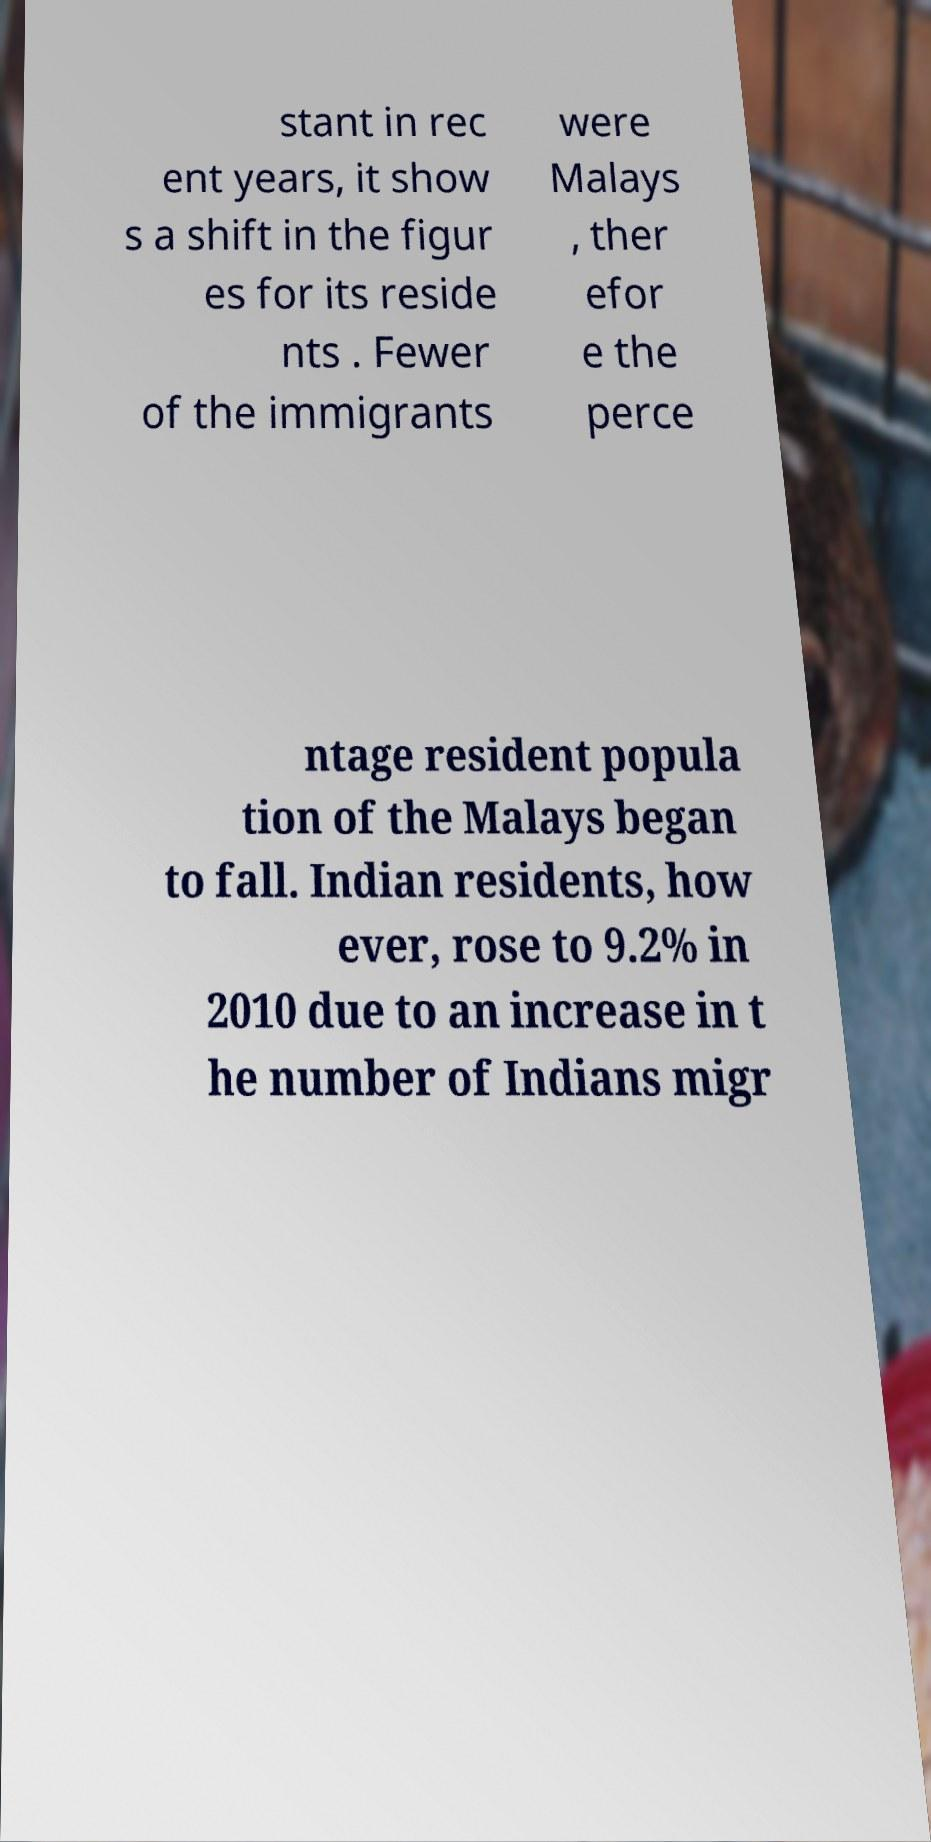Can you read and provide the text displayed in the image?This photo seems to have some interesting text. Can you extract and type it out for me? stant in rec ent years, it show s a shift in the figur es for its reside nts . Fewer of the immigrants were Malays , ther efor e the perce ntage resident popula tion of the Malays began to fall. Indian residents, how ever, rose to 9.2% in 2010 due to an increase in t he number of Indians migr 